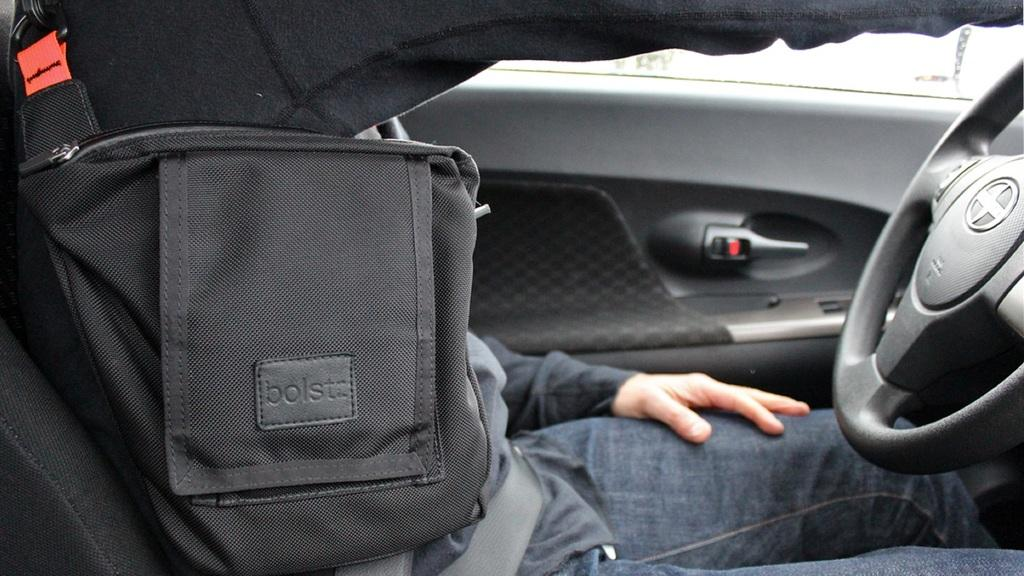Where was the image taken? The image is taken inside a car. What can be seen inside the car? There is a man sitting in the car. On which side of the car is the man sitting? The man is sitting on the left side. Is the man wearing any safety equipment in the image? Yes, the man is wearing a seatbelt. What type of cast can be seen on the man's hands in the image? There is no cast visible on the man's hands in the image. How much sugar is present in the car in the image? There is no mention of sugar in the image, so it cannot be determined how much is present. 